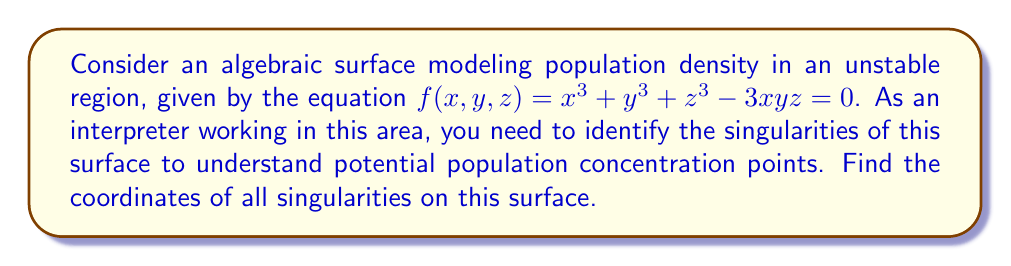Solve this math problem. To find the singularities of the surface, we need to follow these steps:

1) A point $(x,y,z)$ is a singularity if it satisfies $f(x,y,z) = 0$ and all partial derivatives of $f$ are zero at that point.

2) Let's calculate the partial derivatives:

   $$\frac{\partial f}{\partial x} = 3x^2 - 3yz$$
   $$\frac{\partial f}{\partial y} = 3y^2 - 3xz$$
   $$\frac{\partial f}{\partial z} = 3z^2 - 3xy$$

3) For a singularity, we need:

   $$x^3 + y^3 + z^3 - 3xyz = 0$$
   $$3x^2 - 3yz = 0$$
   $$3y^2 - 3xz = 0$$
   $$3z^2 - 3xy = 0$$

4) From the last three equations:

   $$x^2 = yz$$
   $$y^2 = xz$$
   $$z^2 = xy$$

5) Multiplying these equations:

   $$x^2y^2z^2 = y^2z^2x^2$$

   This is always true, so it doesn't give us new information.

6) Let's consider the possible cases:
   
   Case 1: If any of x, y, or z is zero, the other two must also be zero to satisfy the equations in step 4.
   
   Case 2: If none of x, y, z is zero, then from the equations in step 4:
   
   $$x = y = z$$

7) Substituting this into the original equation:

   $$x^3 + x^3 + x^3 - 3x^3 = 0$$
   $$x^3 = 0$$
   $$x = 0$$

8) Therefore, the only singularity is at (0,0,0).

As an interpreter, you can understand this point (0,0,0) as a critical location where population density behavior might change abruptly, potentially indicating a significant cultural or socio-economic boundary in the unstable region.
Answer: (0,0,0) 